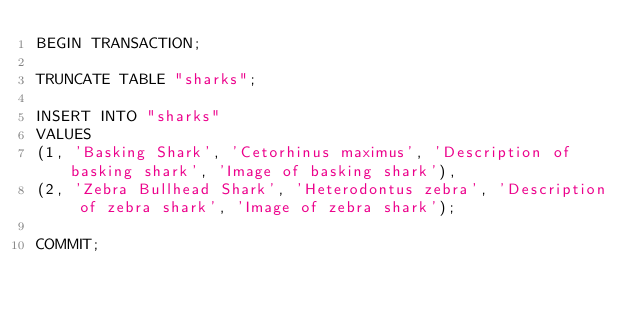Convert code to text. <code><loc_0><loc_0><loc_500><loc_500><_SQL_>BEGIN TRANSACTION;

TRUNCATE TABLE "sharks";

INSERT INTO "sharks"
VALUES
(1, 'Basking Shark', 'Cetorhinus maximus', 'Description of basking shark', 'Image of basking shark'),
(2, 'Zebra Bullhead Shark', 'Heterodontus zebra', 'Description of zebra shark', 'Image of zebra shark');

COMMIT;</code> 